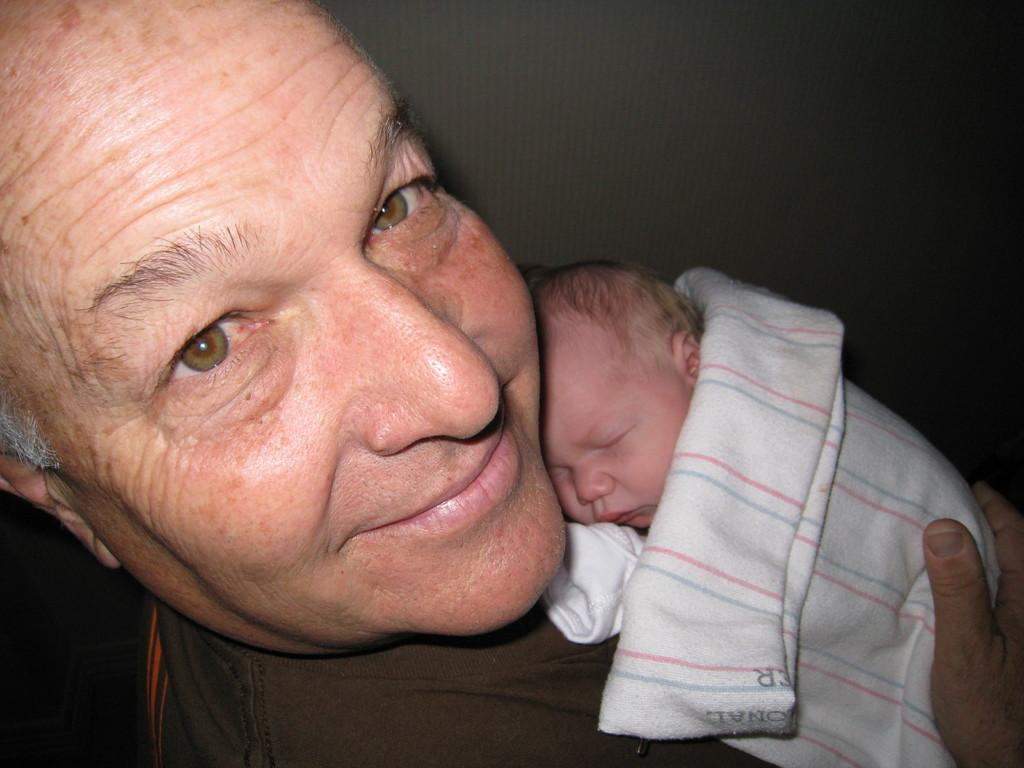Who is present in the image? There is a person in the image. What is the person holding? The person is holding a small baby. What type of drink is the person holding in the image? There is no drink present in the image; the person is holding a small baby. 